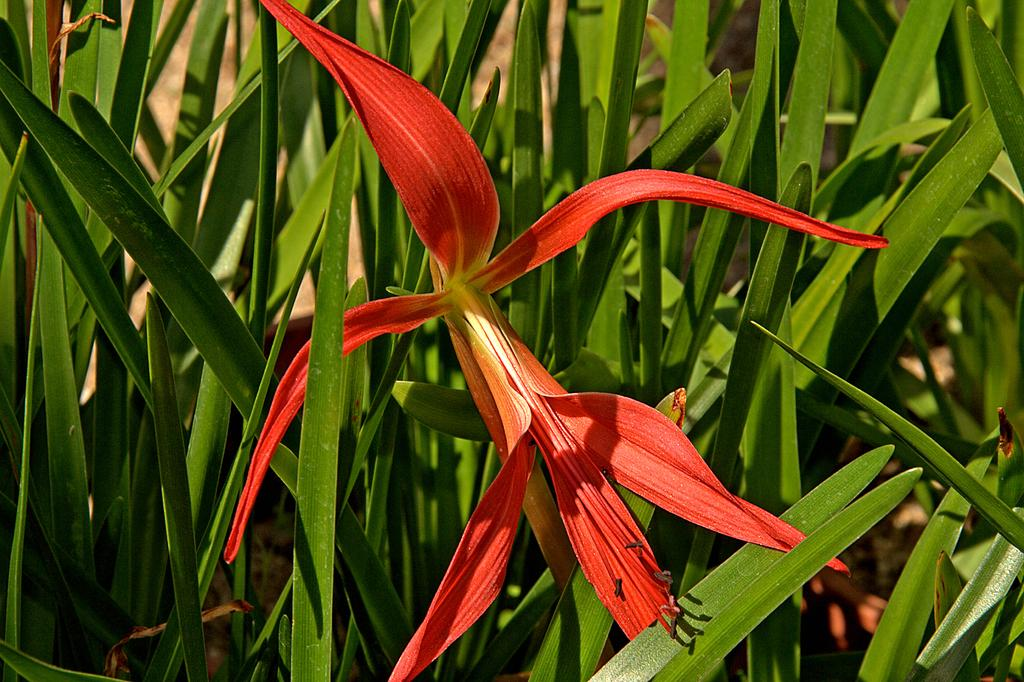What type of plant can be seen in the image? There is a flower in the image. What else can be seen in the image besides the flower? There is greenery in the image. What type of chain is being used to hold the flower in the image? There is no chain present in the image; the flower is not being held by any visible means. 